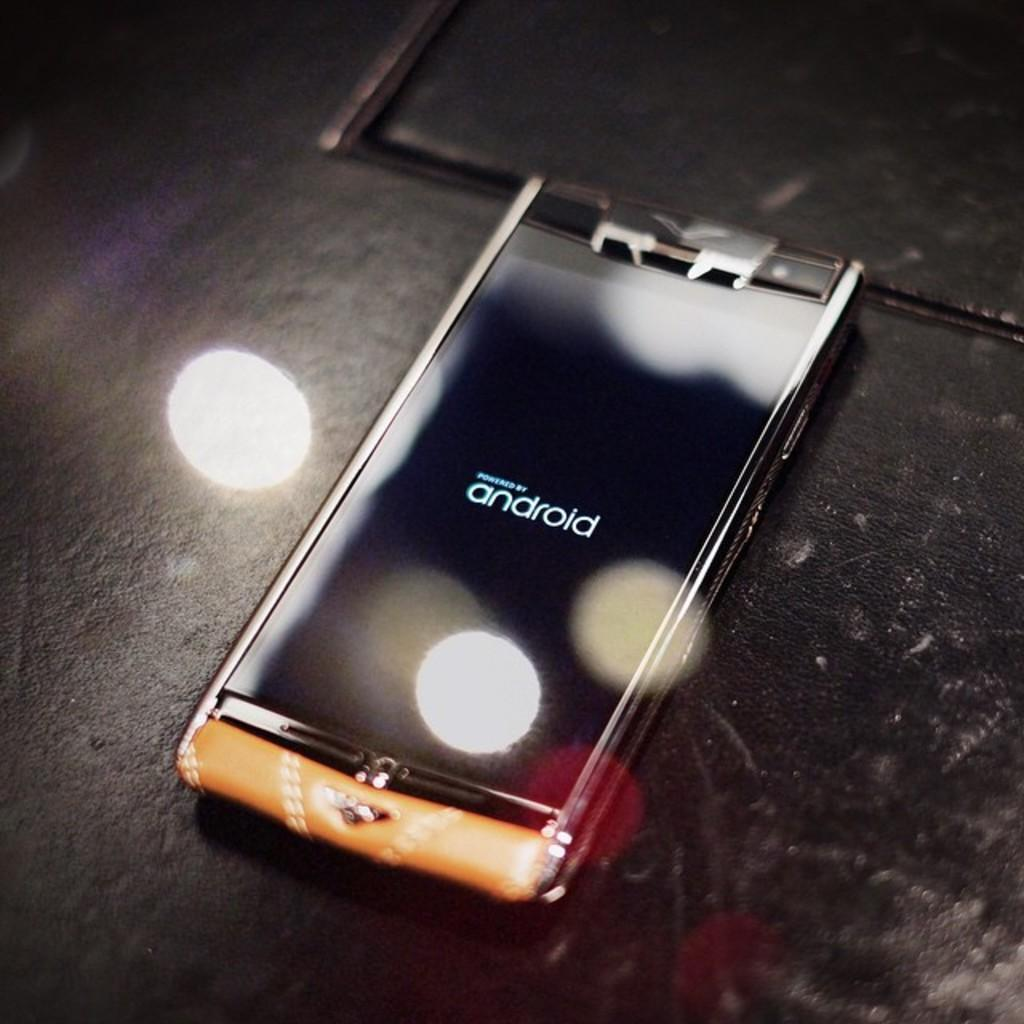<image>
Render a clear and concise summary of the photo. Black android phone on top of a black surface. 